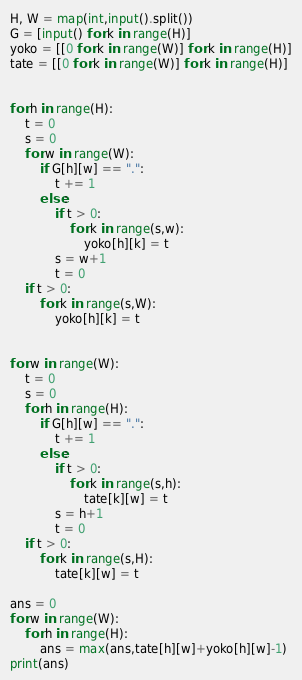<code> <loc_0><loc_0><loc_500><loc_500><_Python_>H, W = map(int,input().split())
G = [input() for k in range(H)]
yoko = [[0 for k in range(W)] for k in range(H)]
tate = [[0 for k in range(W)] for k in range(H)]


for h in range(H):
    t = 0
    s = 0
    for w in range(W):
        if G[h][w] == ".":
            t += 1
        else:
            if t > 0:
                for k in range(s,w):
                    yoko[h][k] = t
            s = w+1
            t = 0
    if t > 0:
        for k in range(s,W):
            yoko[h][k] = t


for w in range(W):
    t = 0
    s = 0
    for h in range(H):
        if G[h][w] == ".":
            t += 1
        else:
            if t > 0:
                for k in range(s,h):
                    tate[k][w] = t
            s = h+1
            t = 0
    if t > 0:
        for k in range(s,H):
            tate[k][w] = t

ans = 0
for w in range(W):
    for h in range(H):
        ans = max(ans,tate[h][w]+yoko[h][w]-1)
print(ans)
</code> 